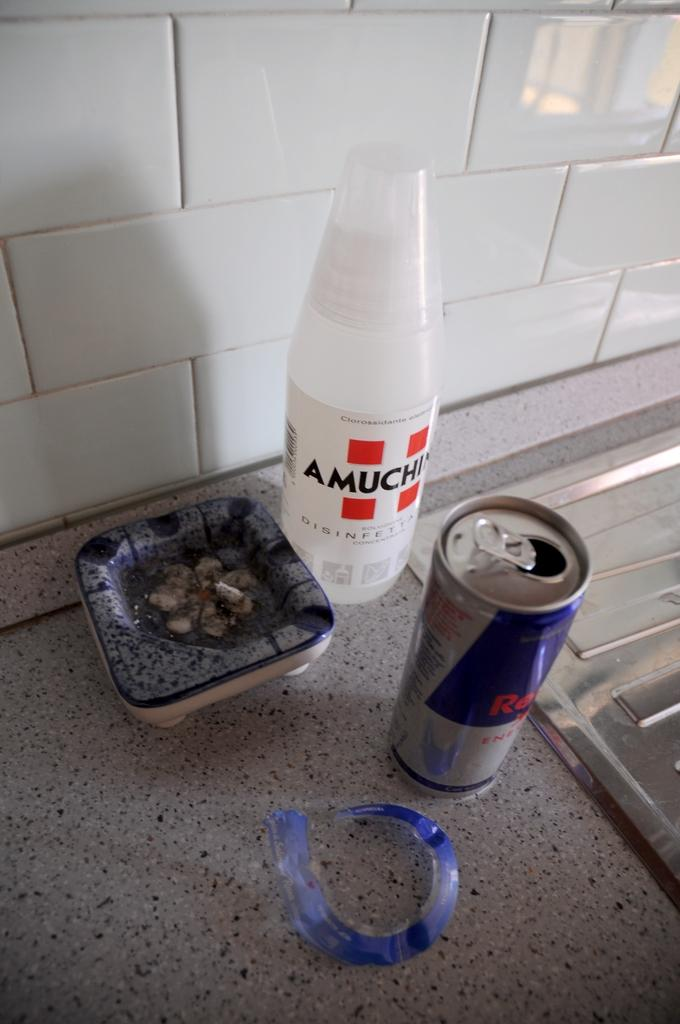<image>
Write a terse but informative summary of the picture. a red bull can sitting next to a sink 